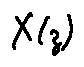Convert formula to latex. <formula><loc_0><loc_0><loc_500><loc_500>X ( z )</formula> 